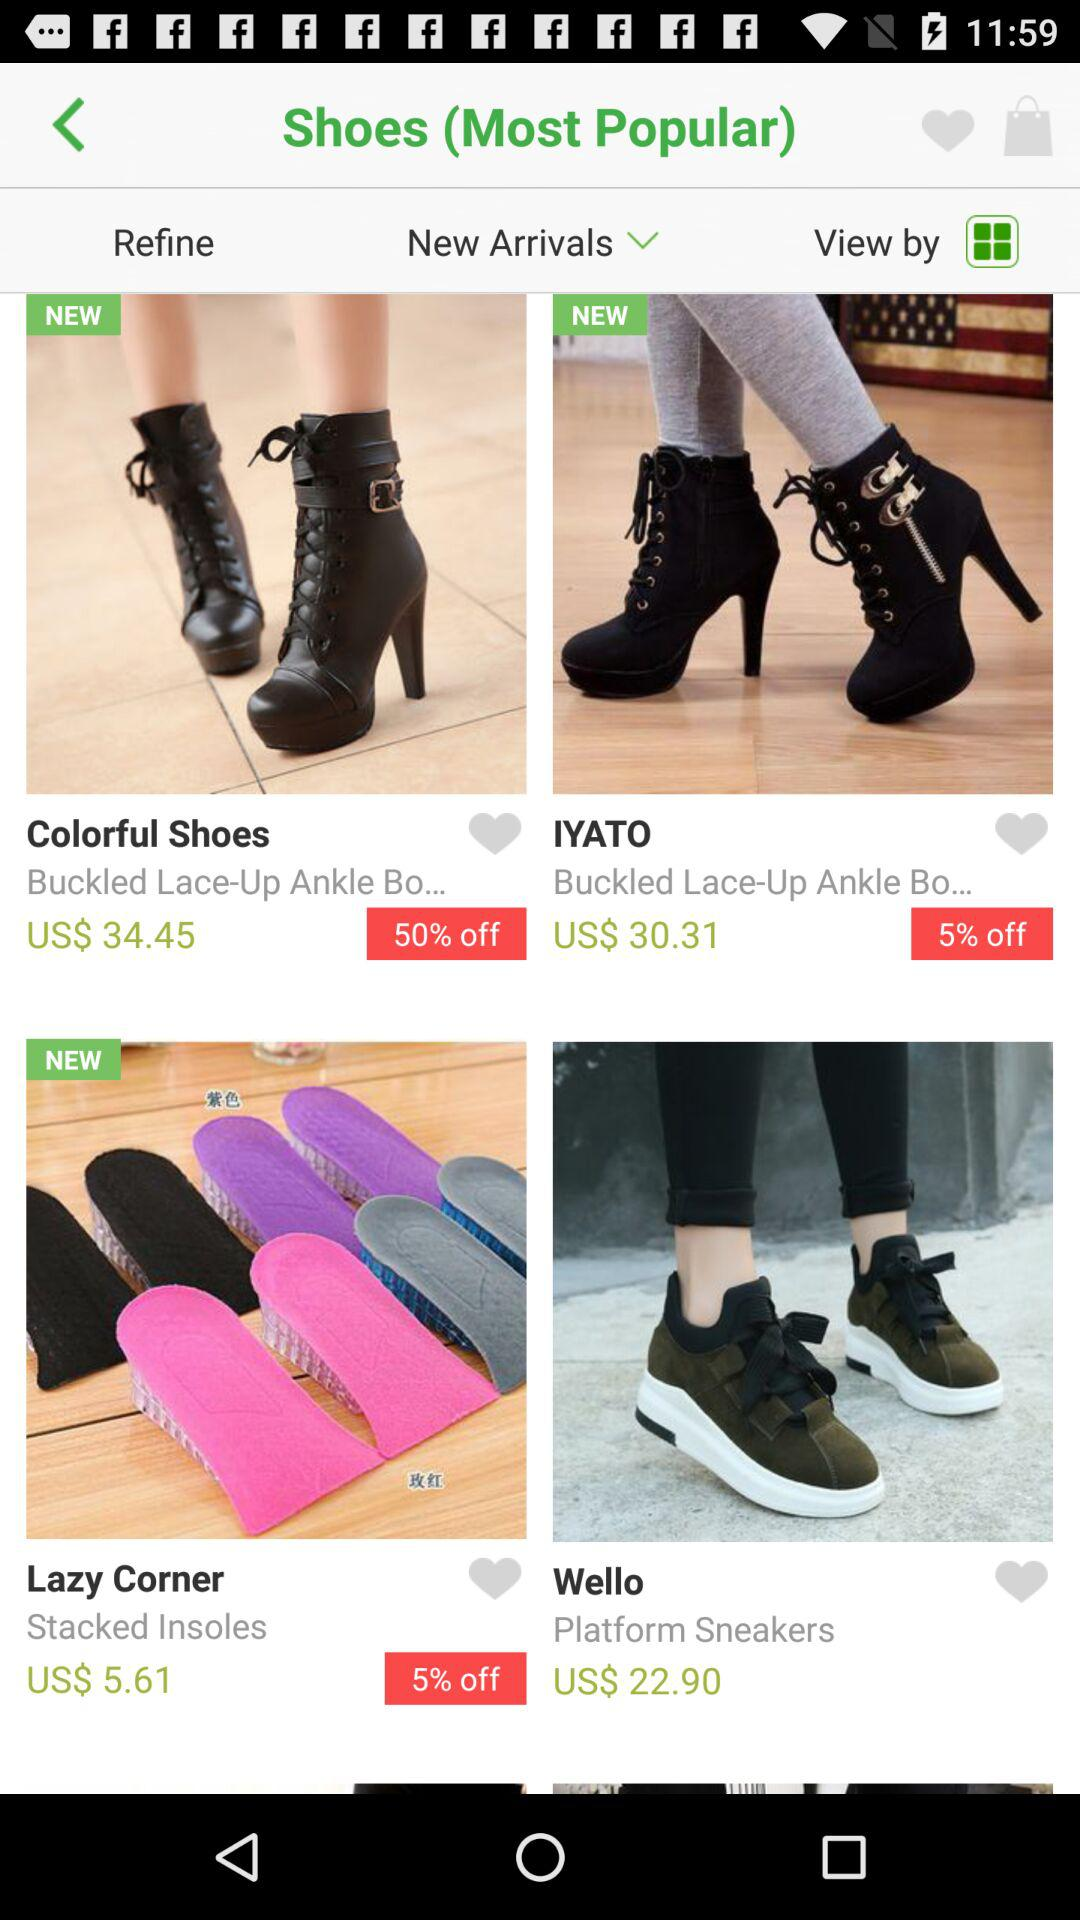What is the discount on the "Colorful Shoes"? The discount on the "Colorful Shoes" is 50%. 